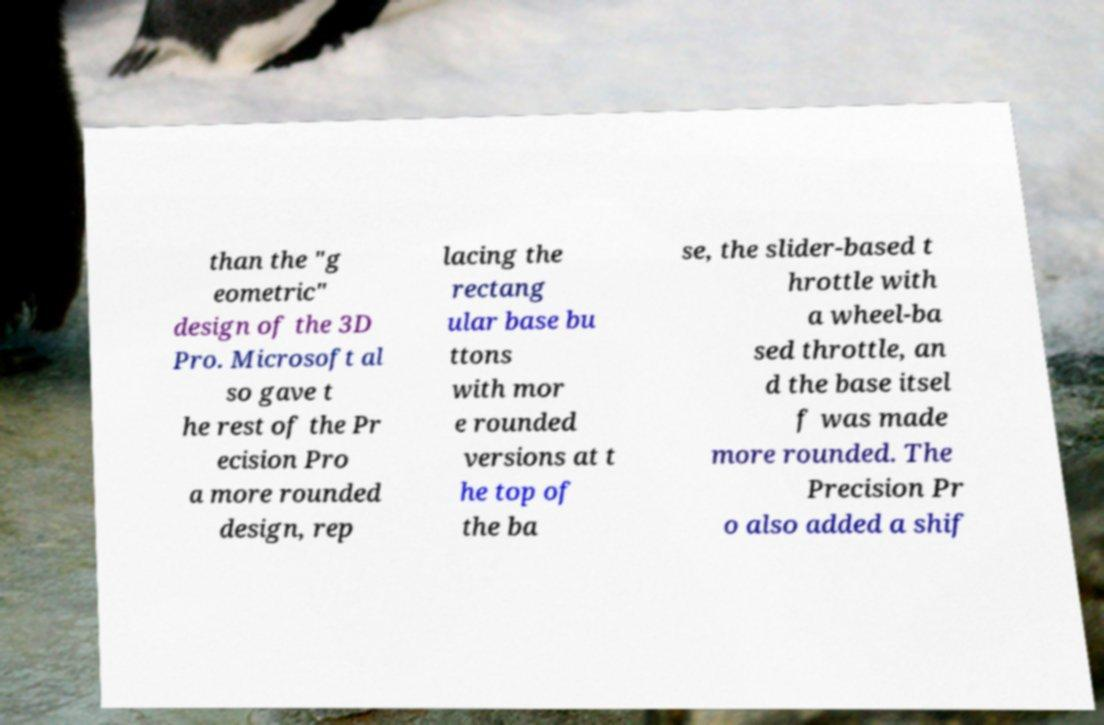What messages or text are displayed in this image? I need them in a readable, typed format. than the "g eometric" design of the 3D Pro. Microsoft al so gave t he rest of the Pr ecision Pro a more rounded design, rep lacing the rectang ular base bu ttons with mor e rounded versions at t he top of the ba se, the slider-based t hrottle with a wheel-ba sed throttle, an d the base itsel f was made more rounded. The Precision Pr o also added a shif 